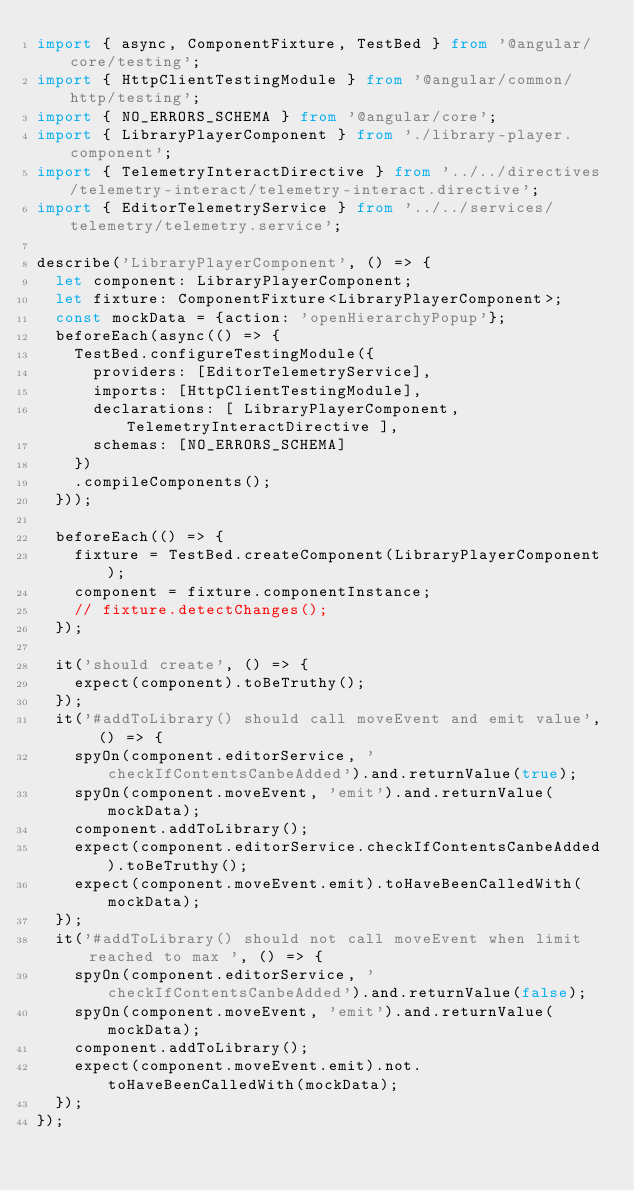Convert code to text. <code><loc_0><loc_0><loc_500><loc_500><_TypeScript_>import { async, ComponentFixture, TestBed } from '@angular/core/testing';
import { HttpClientTestingModule } from '@angular/common/http/testing';
import { NO_ERRORS_SCHEMA } from '@angular/core';
import { LibraryPlayerComponent } from './library-player.component';
import { TelemetryInteractDirective } from '../../directives/telemetry-interact/telemetry-interact.directive';
import { EditorTelemetryService } from '../../services/telemetry/telemetry.service';

describe('LibraryPlayerComponent', () => {
  let component: LibraryPlayerComponent;
  let fixture: ComponentFixture<LibraryPlayerComponent>;
  const mockData = {action: 'openHierarchyPopup'};
  beforeEach(async(() => {
    TestBed.configureTestingModule({
      providers: [EditorTelemetryService],
      imports: [HttpClientTestingModule],
      declarations: [ LibraryPlayerComponent, TelemetryInteractDirective ],
      schemas: [NO_ERRORS_SCHEMA]
    })
    .compileComponents();
  }));

  beforeEach(() => {
    fixture = TestBed.createComponent(LibraryPlayerComponent);
    component = fixture.componentInstance;
    // fixture.detectChanges();
  });

  it('should create', () => {
    expect(component).toBeTruthy();
  });
  it('#addToLibrary() should call moveEvent and emit value', () => {
    spyOn(component.editorService, 'checkIfContentsCanbeAdded').and.returnValue(true);
    spyOn(component.moveEvent, 'emit').and.returnValue(mockData);
    component.addToLibrary();
    expect(component.editorService.checkIfContentsCanbeAdded).toBeTruthy();
    expect(component.moveEvent.emit).toHaveBeenCalledWith(mockData);
  });
  it('#addToLibrary() should not call moveEvent when limit reached to max ', () => {
    spyOn(component.editorService, 'checkIfContentsCanbeAdded').and.returnValue(false);
    spyOn(component.moveEvent, 'emit').and.returnValue(mockData);
    component.addToLibrary();
    expect(component.moveEvent.emit).not.toHaveBeenCalledWith(mockData);
  });
});
</code> 